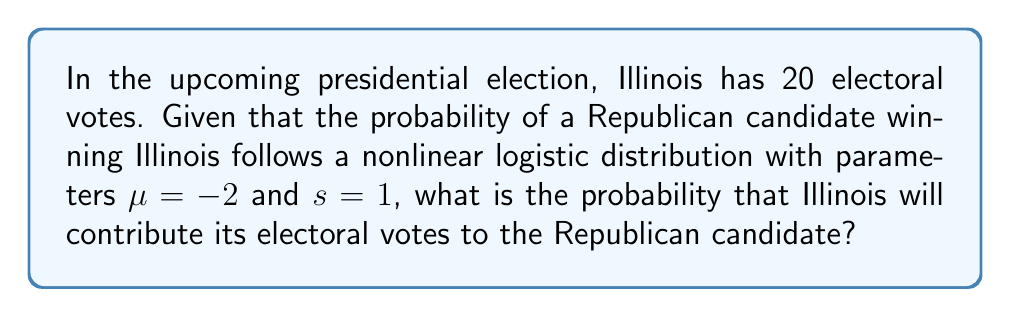Could you help me with this problem? To solve this problem, we'll use the logistic distribution function, which is a nonlinear probability distribution. The cumulative distribution function (CDF) of the logistic distribution is given by:

$$F(x; \mu, s) = \frac{1}{1 + e^{-(x-\mu)/s}}$$

Where:
$\mu$ is the location parameter
$s$ is the scale parameter
$x$ is the value at which we want to evaluate the probability

In this case, we're interested in the probability of the Republican candidate winning, which corresponds to $x = 0$ (the threshold for winning).

Given:
$\mu = -2$
$s = 1$
$x = 0$

Let's substitute these values into the CDF:

$$F(0; -2, 1) = \frac{1}{1 + e^{-(0-(-2))/1}}$$

$$= \frac{1}{1 + e^{2}}$$

$$= \frac{1}{1 + 7.389}$$

$$= \frac{1}{8.389}$$

$$\approx 0.1192$$

Therefore, the probability of the Republican candidate winning Illinois and its 20 electoral votes is approximately 0.1192 or 11.92%.
Answer: 0.1192 